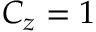Convert formula to latex. <formula><loc_0><loc_0><loc_500><loc_500>C _ { z } = 1</formula> 